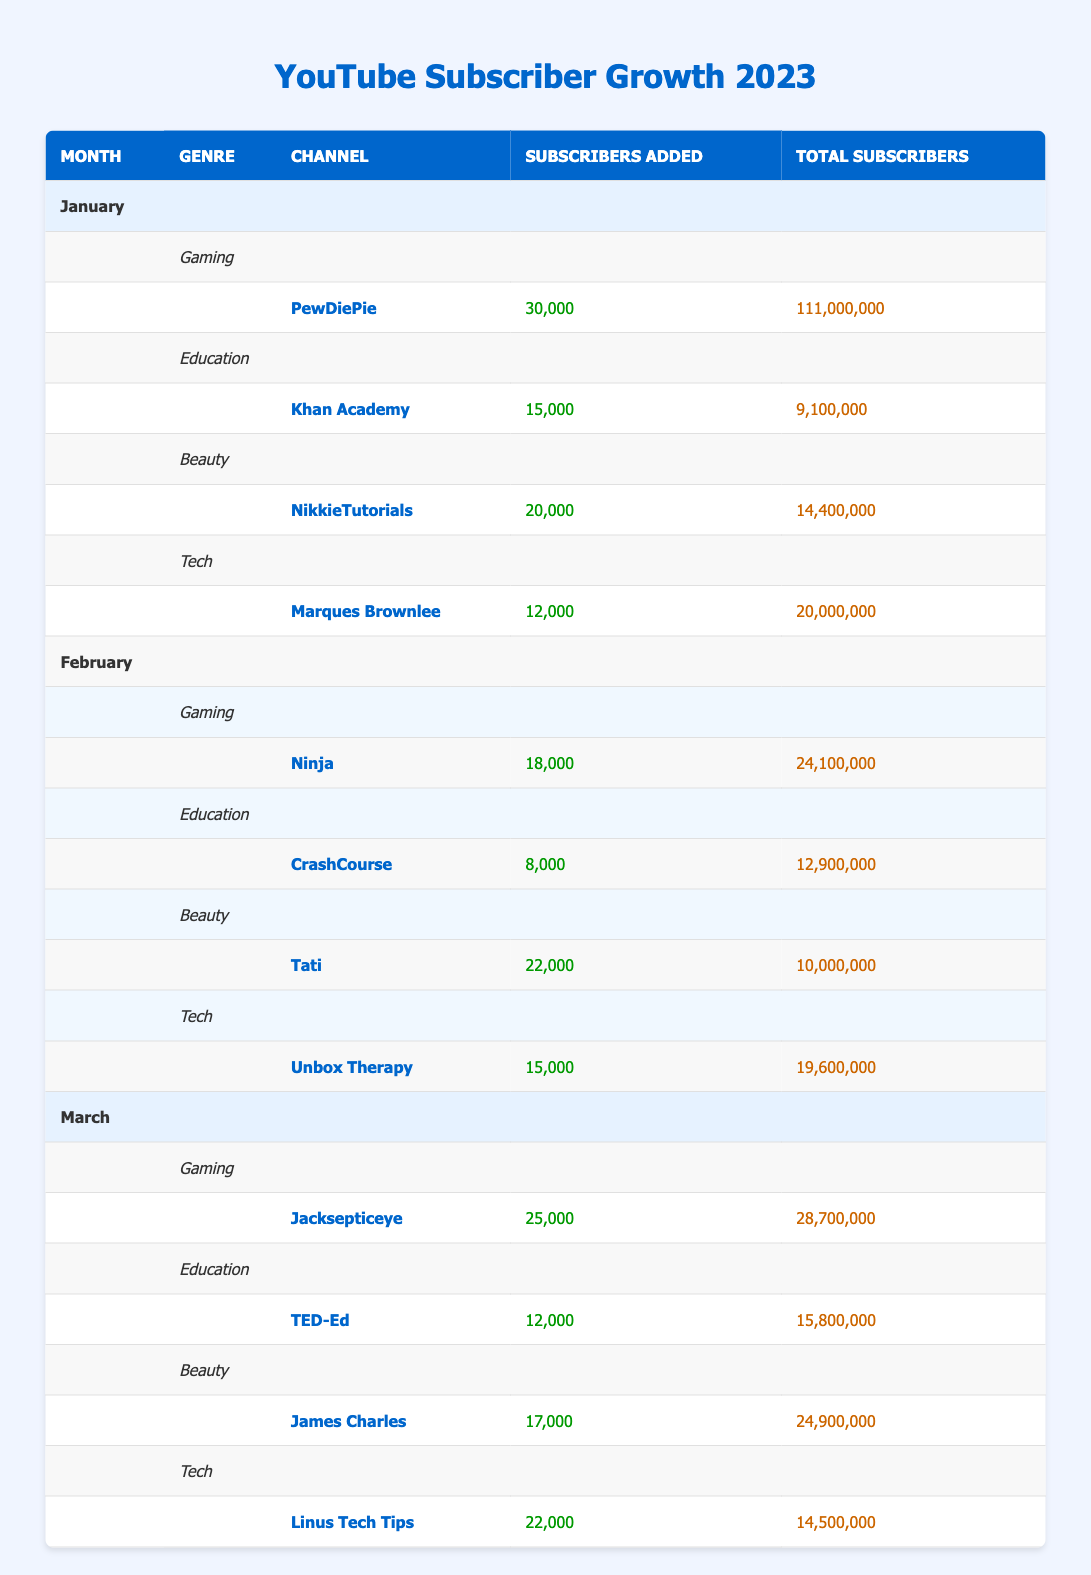What channel had the highest subscriber growth in January? In January, the channel PewDiePie in the Gaming genre added 30,000 subscribers, which is the highest among all channels listed for that month.
Answer: PewDiePie What was the total number of subscribers for NikkieTutorials in January? According to the table, NikkieTutorials had a total of 14,400,000 subscribers in January, which is clearly stated in the Total Subscribers column.
Answer: 14,400,000 Which genre experienced the highest subscriber growth in March? In March, the Gaming genre had Jacksepticeye adding 25,000 subscribers, while Education (TED-Ed), Beauty (James Charles), and Tech (Linus Tech Tips) added 12,000, 17,000, and 22,000 respectively. The Gaming genre had the highest growth with 25,000 subscribers added.
Answer: Gaming What was the average subscriber growth for the Tech genre across all three months? The subscriber additions for Tech in the three months are: January 12,000, February 15,000, and March 22,000. Summing these values gives 12,000 + 15,000 + 22,000 = 49,000. To find the average, divide by 3, resulting in 49,000 / 3 = 16,333.33.
Answer: 16,333 Did Tati add more subscribers in February than Khan Academy added in January? Tati added 22,000 subscribers in February, while Khan Academy added 15,000 subscribers in January. Since 22,000 is greater than 15,000, the answer is yes.
Answer: Yes What is the total number of subscribers for all channels listed in February? To find the total subscribers for February, we add: Ninja (24,100,000) + CrashCourse (12,900,000) + Tati (10,000,000) + Unbox Therapy (19,600,000). The total is 24,100,000 + 12,900,000 + 10,000,000 + 19,600,000 = 76,600,000.
Answer: 76,600,000 Which month had a channel with the least subscriber addition? In January, Marques Brownlee added only 12,000 subscribers in the Tech genre, which is less than any other monthly addition listed across all channels.
Answer: January What was the increase in total subscribers for James Charles from January to March? James Charles had 24,900,000 subscribers in March and 17,000 subscribers added in March, while in January, Beauty genre had a different channel (NikkieTutorials) with 14,400,000. We do not have a direct comparison for James Charles, but he was not listed in January, so the increase in total subscribers for him can be seen from 0 to 24,900,000.
Answer: 24,900,000 How did the subscriber growth of Education in March compare to the previous months? In January, Education (Khan Academy) added 15,000 subscribers, in February (CrashCourse) added 8,000, and in March (TED-Ed) added 12,000. Compared to January (15,000) and February (8,000), March's 12,000 was greater than February but less than January.
Answer: Less than January, more than February 